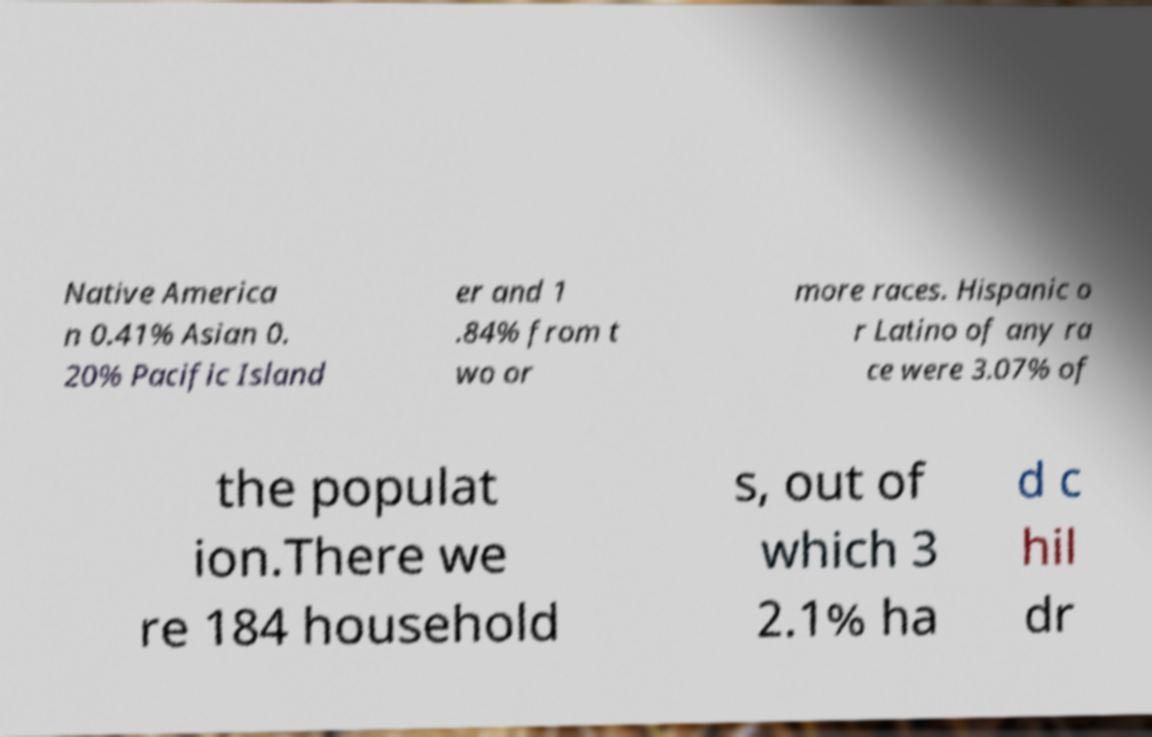I need the written content from this picture converted into text. Can you do that? Native America n 0.41% Asian 0. 20% Pacific Island er and 1 .84% from t wo or more races. Hispanic o r Latino of any ra ce were 3.07% of the populat ion.There we re 184 household s, out of which 3 2.1% ha d c hil dr 